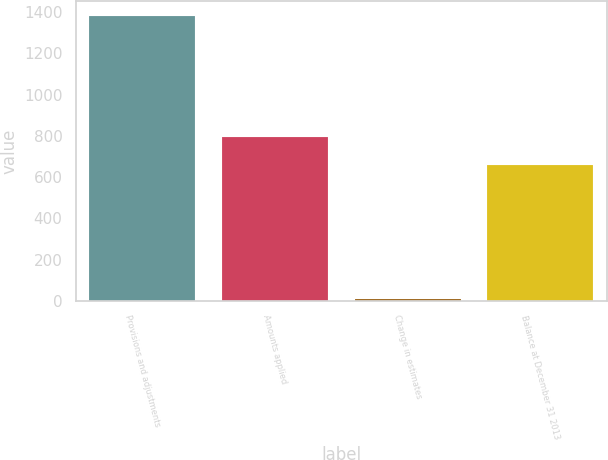Convert chart to OTSL. <chart><loc_0><loc_0><loc_500><loc_500><bar_chart><fcel>Provisions and adjustments<fcel>Amounts applied<fcel>Change in estimates<fcel>Balance at December 31 2013<nl><fcel>1383<fcel>795.4<fcel>9<fcel>658<nl></chart> 